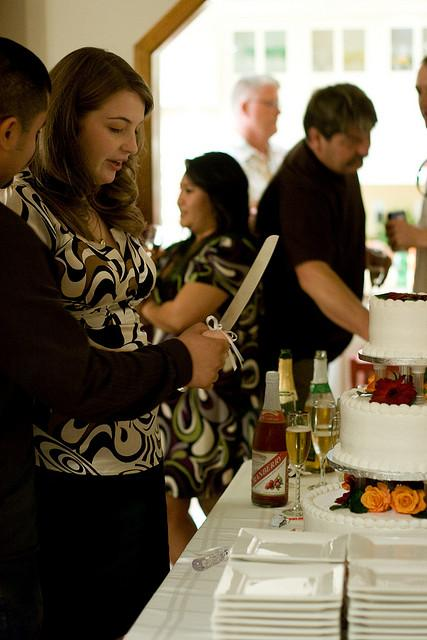What did this lady do on the day she holds this knife? get married 